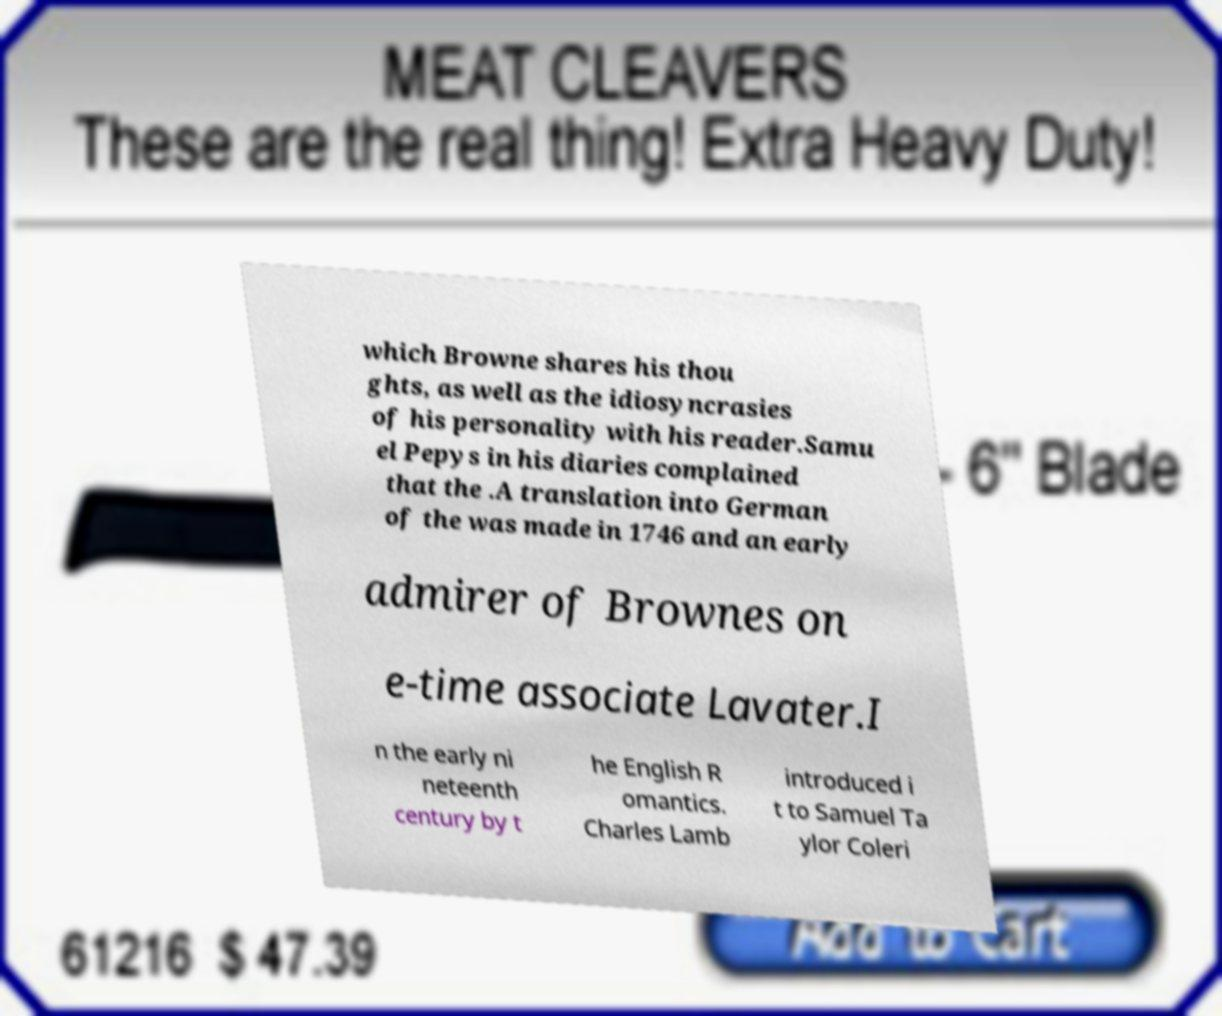What messages or text are displayed in this image? I need them in a readable, typed format. which Browne shares his thou ghts, as well as the idiosyncrasies of his personality with his reader.Samu el Pepys in his diaries complained that the .A translation into German of the was made in 1746 and an early admirer of Brownes on e-time associate Lavater.I n the early ni neteenth century by t he English R omantics. Charles Lamb introduced i t to Samuel Ta ylor Coleri 